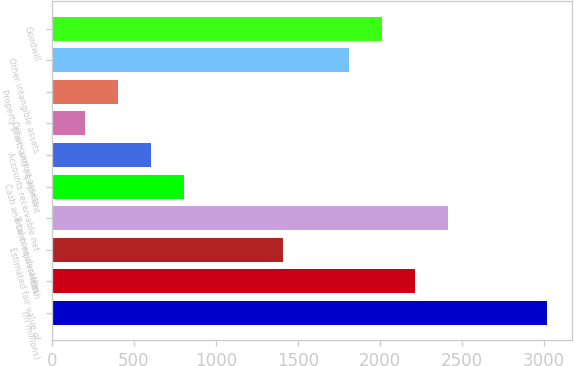<chart> <loc_0><loc_0><loc_500><loc_500><bar_chart><fcel>(In millions)<fcel>Cash<fcel>Estimated fair value of<fcel>Total consideration<fcel>Cash and cash equivalents<fcel>Accounts receivable net<fcel>Other current assets<fcel>Property plant and equipment<fcel>Other intangible assets<fcel>Goodwill<nl><fcel>3021<fcel>2216.2<fcel>1411.4<fcel>2417.4<fcel>807.8<fcel>606.6<fcel>204.2<fcel>405.4<fcel>1813.8<fcel>2015<nl></chart> 